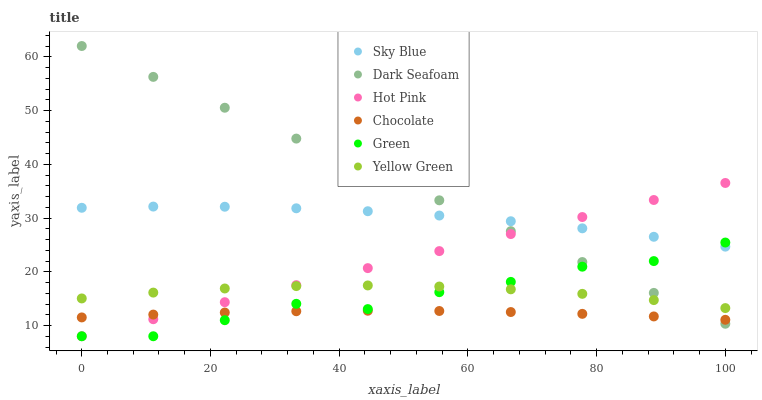Does Chocolate have the minimum area under the curve?
Answer yes or no. Yes. Does Dark Seafoam have the maximum area under the curve?
Answer yes or no. Yes. Does Hot Pink have the minimum area under the curve?
Answer yes or no. No. Does Hot Pink have the maximum area under the curve?
Answer yes or no. No. Is Hot Pink the smoothest?
Answer yes or no. Yes. Is Green the roughest?
Answer yes or no. Yes. Is Chocolate the smoothest?
Answer yes or no. No. Is Chocolate the roughest?
Answer yes or no. No. Does Hot Pink have the lowest value?
Answer yes or no. Yes. Does Chocolate have the lowest value?
Answer yes or no. No. Does Dark Seafoam have the highest value?
Answer yes or no. Yes. Does Hot Pink have the highest value?
Answer yes or no. No. Is Chocolate less than Yellow Green?
Answer yes or no. Yes. Is Sky Blue greater than Chocolate?
Answer yes or no. Yes. Does Sky Blue intersect Green?
Answer yes or no. Yes. Is Sky Blue less than Green?
Answer yes or no. No. Is Sky Blue greater than Green?
Answer yes or no. No. Does Chocolate intersect Yellow Green?
Answer yes or no. No. 